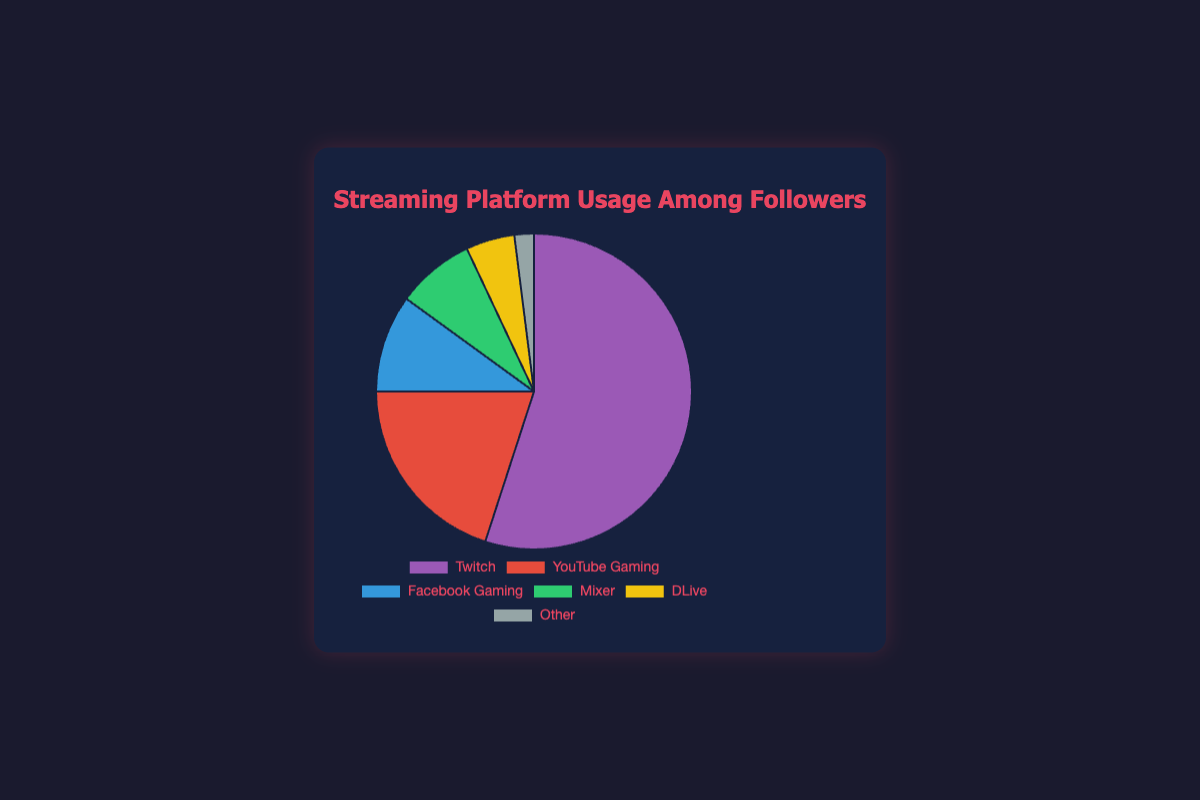What platform has the highest usage among followers? By looking at the pie chart, the largest segment will represent the platform with the highest percentage. The color doesn't matter; what matters is the size of the segment. From the data provided, Twitch has the highest percentage.
Answer: Twitch What is the combined usage percentage of Mixer and DLive? To get the combined percentage, add the values for Mixer (8%) and DLive (5%). The sum of 8 and 5 is 13.
Answer: 13% Which platforms have a usage percentage less than 10%? Identify segments in the pie chart that are less than a tenth of the chart. From the data, Facebook Gaming, Mixer, DLive, and Other all fall below 10%.
Answer: Facebook Gaming, Mixer, DLive, Other What is the difference in usage percentage between Twitch and YouTube Gaming? Find the segments for Twitch and YouTube Gaming, noting their percentage values. The difference between Twitch (55%) and YouTube Gaming (20%) is calculated by subtracting the smaller value from the larger, i.e., 55 - 20.
Answer: 35% What platforms together make up the smallest combined usage percentage? Identify the platforms taking up the smallest portions of the pie chart, which would be the ones on the tail end of the percentage list. The two smallest values are for DLive (5%) and Other (2%). Adding these gives 5 + 2.
Answer: DLive, Other Which platform's segment on the pie chart is represented with the color green? Look for the segment colored green and refer to the corresponding label in the legend. According to the data provided for the chart, Mixer is colored green.
Answer: Mixer How much larger is the percentage of Twitch compared to Facebook Gaming? Identify the percentage values for Twitch (55%) and Facebook Gaming (10%). Subtract the Facebook Gaming value from the Twitch value to find the difference, i.e., 55 - 10.
Answer: 45% What is the combined usage percentage of all platforms except Twitch? To find this, sum the percentages of all platforms other than Twitch. These are YouTube Gaming (20%), Facebook Gaming (10%), Mixer (8%), DLive (5%), and Other (2%). The total is 20 + 10 + 8 + 5 + 2.
Answer: 45% Which platform has the smallest usage among followers? Look at the smallest segment in the pie chart to determine which one is the smallest. The data indicates that "Other" has the smallest percentage at 2%.
Answer: Other What is the average usage percentage of the platforms excluding Twitch? To find the average, add up the percentages of YouTube Gaming (20%), Facebook Gaming (10%), Mixer (8%), DLive (5%), and Other (2%) and then divide by the number of these platforms, which is 5. The sum is 20 + 10 + 8 + 5 + 2 = 45, and the average is 45 / 5.
Answer: 9% 